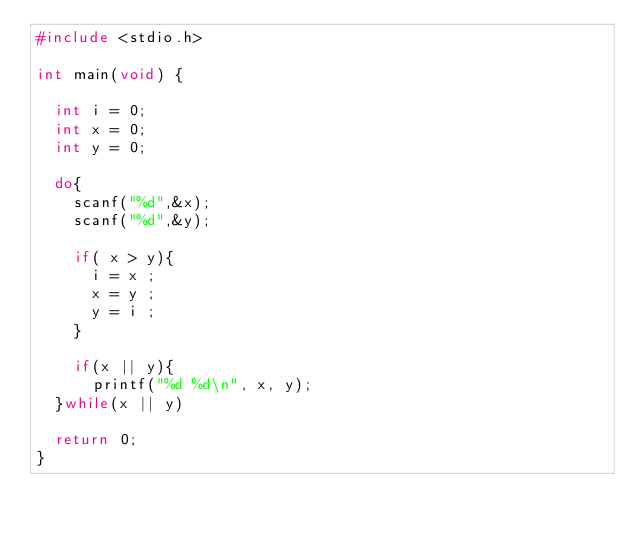Convert code to text. <code><loc_0><loc_0><loc_500><loc_500><_C_>#include <stdio.h>

int main(void) {

	int i = 0;
	int x = 0;
	int y = 0;

	do{
		scanf("%d",&x);
		scanf("%d",&y);
		
		if( x > y){
			i = x ;
			x = y ;
			y = i ;
		}
		
		if(x || y){
			printf("%d %d\n", x, y);
	}while(x || y)

	return 0;
}</code> 